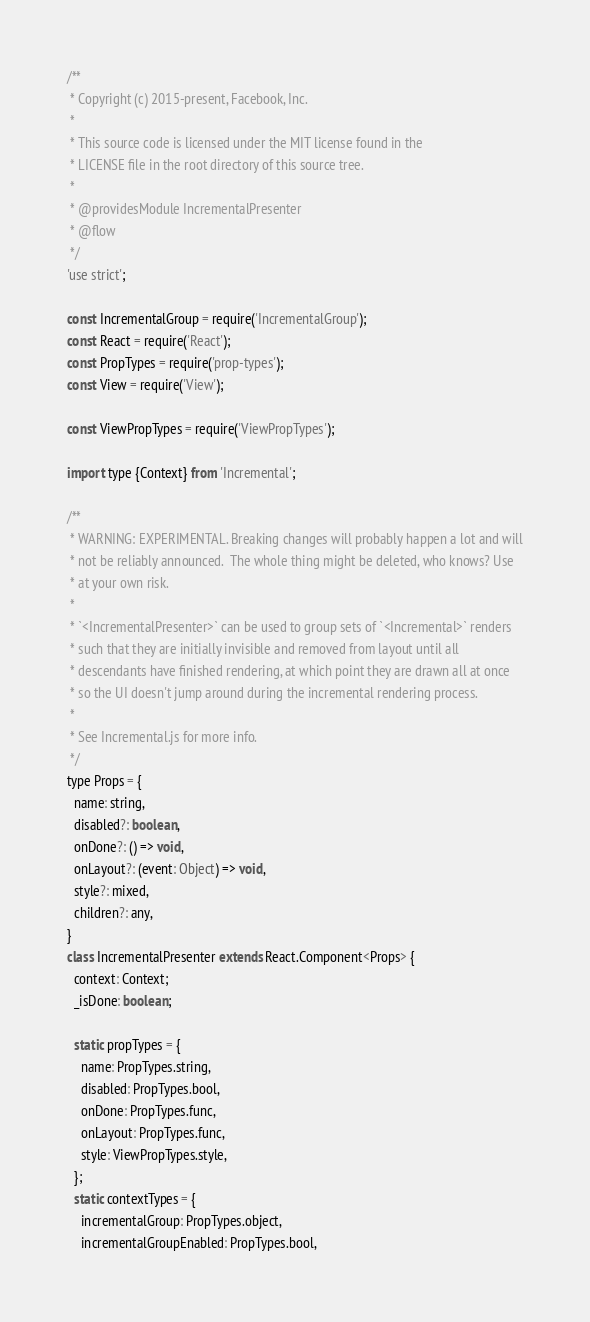Convert code to text. <code><loc_0><loc_0><loc_500><loc_500><_JavaScript_>/**
 * Copyright (c) 2015-present, Facebook, Inc.
 *
 * This source code is licensed under the MIT license found in the
 * LICENSE file in the root directory of this source tree.
 *
 * @providesModule IncrementalPresenter
 * @flow
 */
'use strict';

const IncrementalGroup = require('IncrementalGroup');
const React = require('React');
const PropTypes = require('prop-types');
const View = require('View');

const ViewPropTypes = require('ViewPropTypes');

import type {Context} from 'Incremental';

/**
 * WARNING: EXPERIMENTAL. Breaking changes will probably happen a lot and will
 * not be reliably announced.  The whole thing might be deleted, who knows? Use
 * at your own risk.
 *
 * `<IncrementalPresenter>` can be used to group sets of `<Incremental>` renders
 * such that they are initially invisible and removed from layout until all
 * descendants have finished rendering, at which point they are drawn all at once
 * so the UI doesn't jump around during the incremental rendering process.
 *
 * See Incremental.js for more info.
 */
type Props = {
  name: string,
  disabled?: boolean,
  onDone?: () => void,
  onLayout?: (event: Object) => void,
  style?: mixed,
  children?: any,
}
class IncrementalPresenter extends React.Component<Props> {
  context: Context;
  _isDone: boolean;

  static propTypes = {
    name: PropTypes.string,
    disabled: PropTypes.bool,
    onDone: PropTypes.func,
    onLayout: PropTypes.func,
    style: ViewPropTypes.style,
  };
  static contextTypes = {
    incrementalGroup: PropTypes.object,
    incrementalGroupEnabled: PropTypes.bool,</code> 